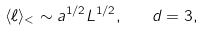Convert formula to latex. <formula><loc_0><loc_0><loc_500><loc_500>\langle \ell \rangle _ { < } \sim a ^ { 1 / 2 } L ^ { 1 / 2 } , \quad d = 3 ,</formula> 